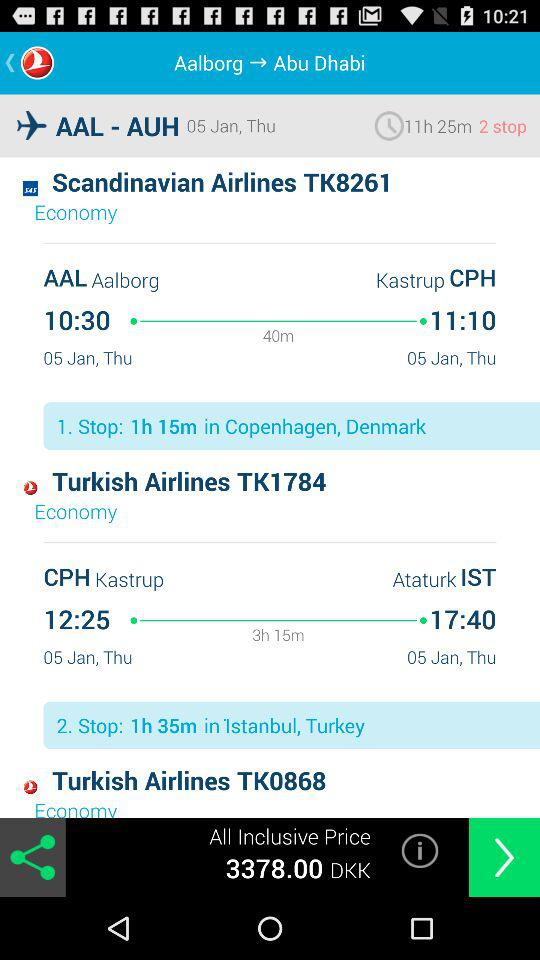What is the departure date of the "Turkish Airlines" flight? The departure date of the "Turkish Airlines" flight is Thursday, January 5. 